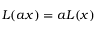<formula> <loc_0><loc_0><loc_500><loc_500>L ( a x ) = a L ( x )</formula> 